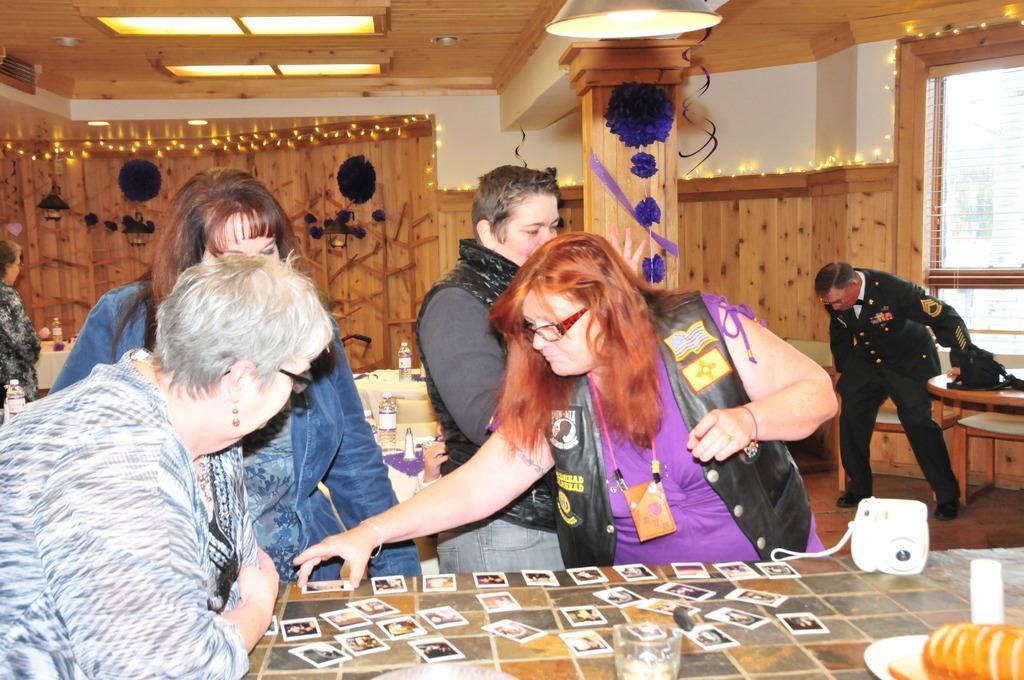In one or two sentences, can you explain what this image depicts? In the image we can see four persons were standing around the table. On table,there is a glass,plate,camera,fruit and cards. In the background we can see wood wall,light,pillar,window,table,chair,bottle and two persons were standing. 